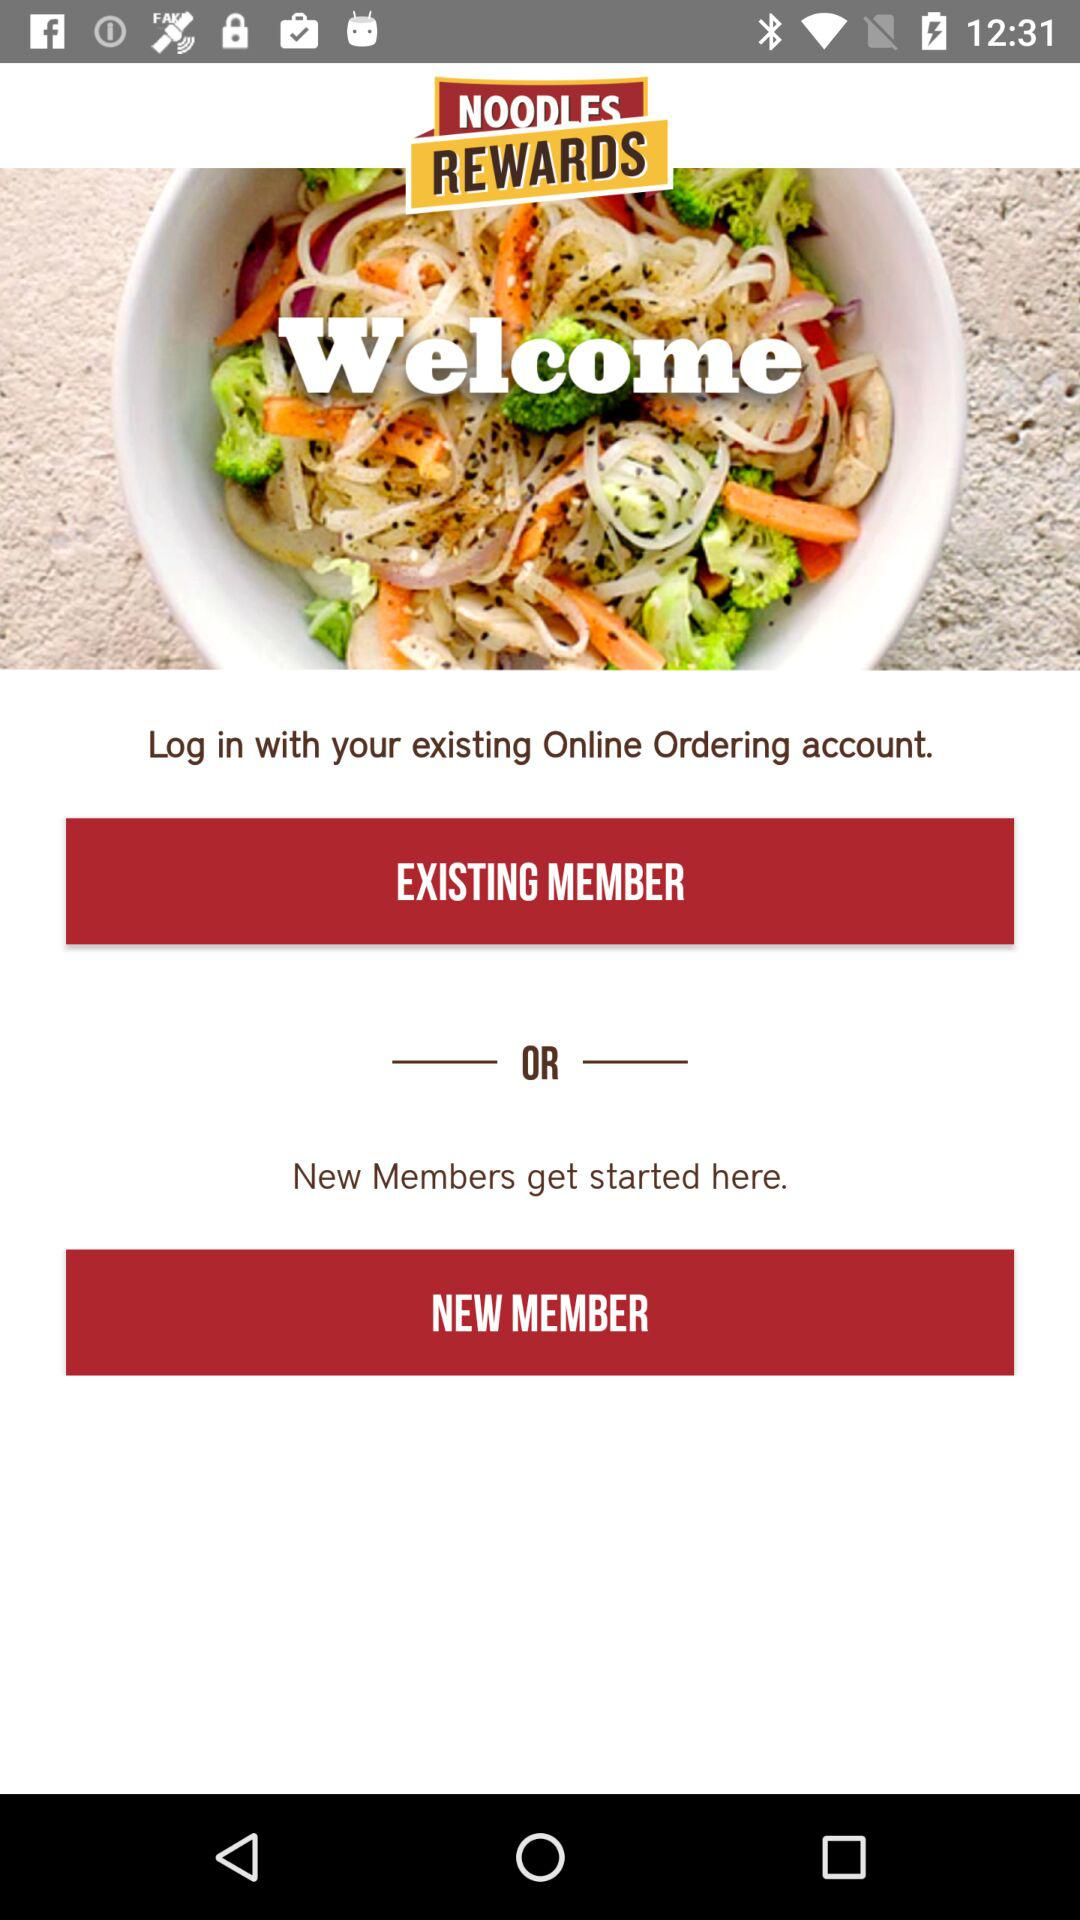What is the application Name?
When the provided information is insufficient, respond with <no answer>. <no answer> 